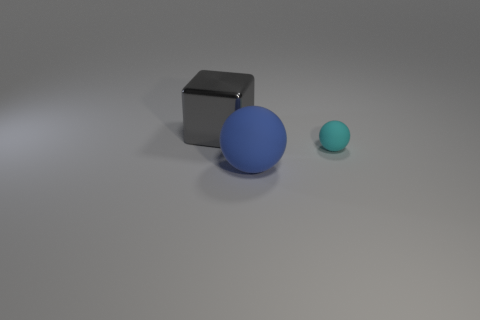Subtract all cyan balls. Subtract all brown cylinders. How many balls are left? 1 Add 2 big blue balls. How many objects exist? 5 Subtract all blocks. How many objects are left? 2 Subtract 1 gray cubes. How many objects are left? 2 Subtract all large blue cylinders. Subtract all gray objects. How many objects are left? 2 Add 2 big matte spheres. How many big matte spheres are left? 3 Add 2 large gray matte objects. How many large gray matte objects exist? 2 